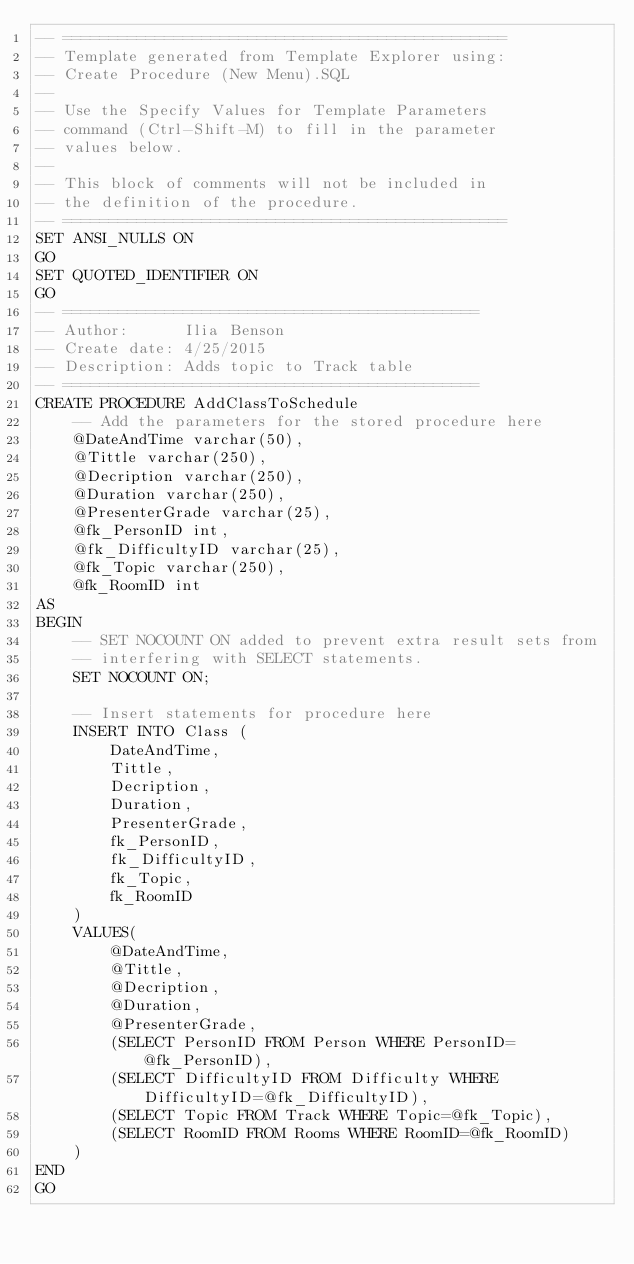Convert code to text. <code><loc_0><loc_0><loc_500><loc_500><_SQL_>-- ================================================
-- Template generated from Template Explorer using:
-- Create Procedure (New Menu).SQL
--
-- Use the Specify Values for Template Parameters 
-- command (Ctrl-Shift-M) to fill in the parameter 
-- values below.
--
-- This block of comments will not be included in
-- the definition of the procedure.
-- ================================================
SET ANSI_NULLS ON
GO
SET QUOTED_IDENTIFIER ON
GO
-- =============================================
-- Author:		Ilia Benson
-- Create date: 4/25/2015
-- Description:	Adds topic to Track table
-- =============================================
CREATE PROCEDURE AddClassToSchedule
	-- Add the parameters for the stored procedure here
	@DateAndTime varchar(50),
	@Tittle varchar(250),
	@Decription varchar(250),
	@Duration varchar(250),
	@PresenterGrade varchar(25),
	@fk_PersonID int,
	@fk_DifficultyID varchar(25),
	@fk_Topic varchar(250),
	@fk_RoomID int
AS
BEGIN
	-- SET NOCOUNT ON added to prevent extra result sets from
	-- interfering with SELECT statements.
	SET NOCOUNT ON;

    -- Insert statements for procedure here
	INSERT INTO Class (
		DateAndTime,
		Tittle,
		Decription,
		Duration,
		PresenterGrade,
		fk_PersonID,
		fk_DifficultyID,
		fk_Topic,
		fk_RoomID
	)
    VALUES(
		@DateAndTime,
		@Tittle,
		@Decription,
		@Duration,
		@PresenterGrade,
		(SELECT PersonID FROM Person WHERE PersonID=@fk_PersonID),
		(SELECT DifficultyID FROM Difficulty WHERE DifficultyID=@fk_DifficultyID),
		(SELECT Topic FROM Track WHERE Topic=@fk_Topic),
		(SELECT RoomID FROM Rooms WHERE RoomID=@fk_RoomID)
	)
END
GO</code> 